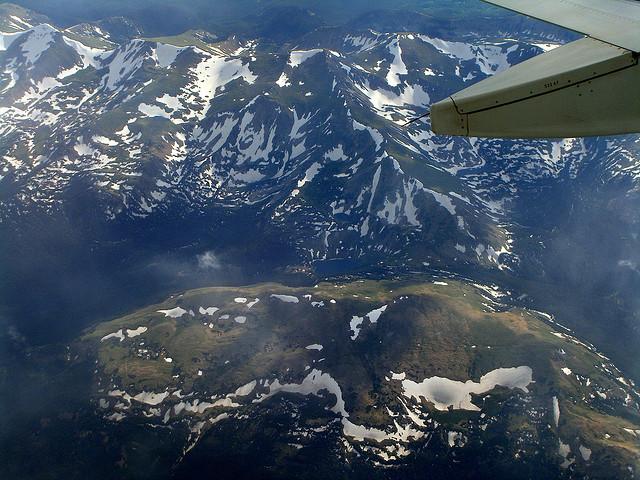Did the pilot flying the plane take this photo?
Answer briefly. No. Is this photo taken low to the ground?
Give a very brief answer. No. Is there snow on the ground?
Give a very brief answer. Yes. Is this an aerial view of the mountains?
Keep it brief. Yes. 